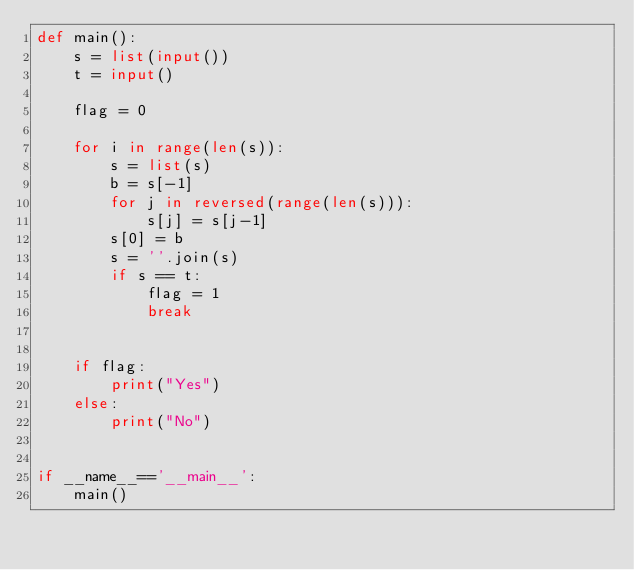<code> <loc_0><loc_0><loc_500><loc_500><_Python_>def main():
    s = list(input())
    t = input()

    flag = 0

    for i in range(len(s)):
        s = list(s)
        b = s[-1]
        for j in reversed(range(len(s))):
            s[j] = s[j-1]
        s[0] = b
        s = ''.join(s)
        if s == t:
            flag = 1
            break


    if flag:
        print("Yes")
    else:
        print("No")
       

if __name__=='__main__':
    main()
</code> 